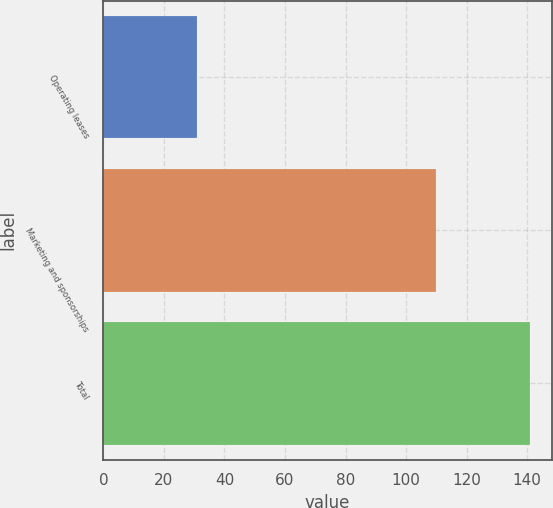Convert chart. <chart><loc_0><loc_0><loc_500><loc_500><bar_chart><fcel>Operating leases<fcel>Marketing and sponsorships<fcel>Total<nl><fcel>31<fcel>110<fcel>141<nl></chart> 